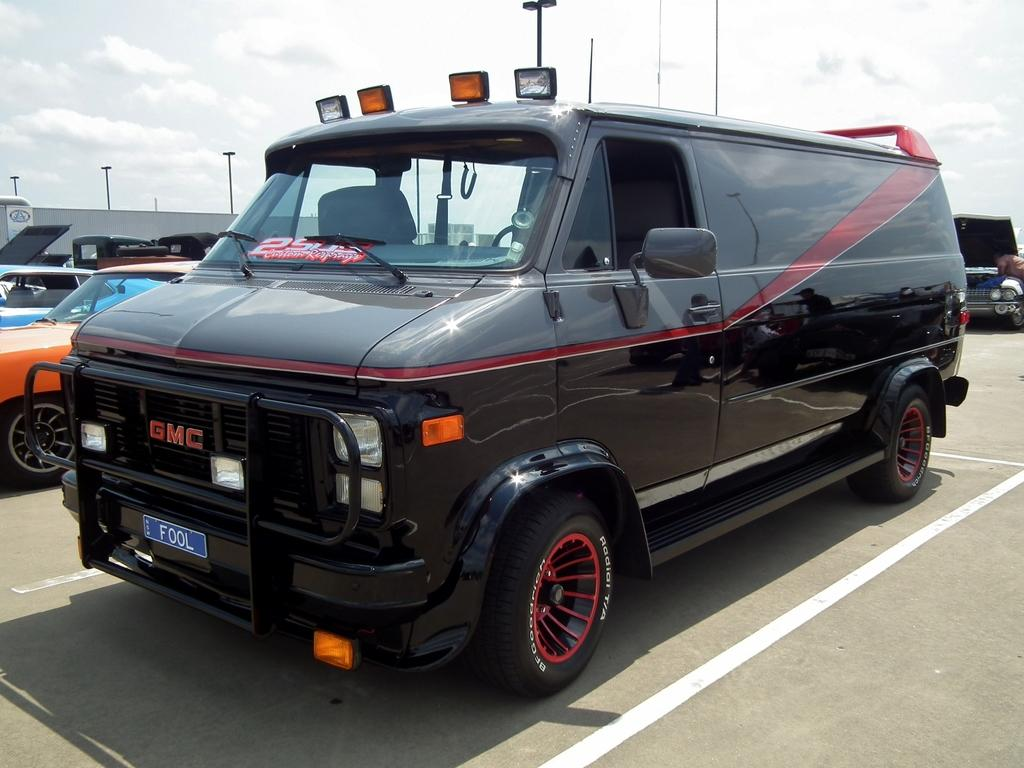What can be seen in large numbers in the image? There are many vehicles in the image. What is visible in the sky in the image? There are clouds in the sky. What structure is located at the left side of the image? There is a shed at the left side of the image. What safety features are visible on the road in the image? Road safety markings are visible on the road. What type of cast can be seen on the driver's arm in the image? There is no cast visible on anyone's arm in the image, as the focus is on the vehicles and the road safety markings. 